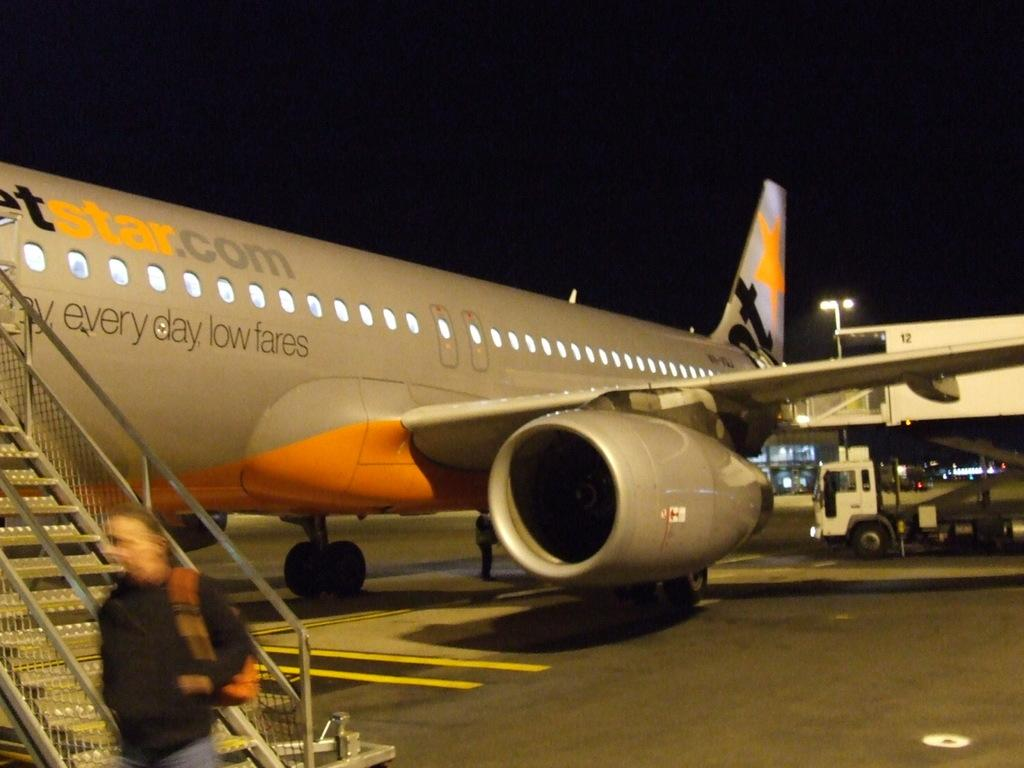<image>
Write a terse but informative summary of the picture. An airplane advertising every day low fares has a set of stairs leading to the tarmac. 